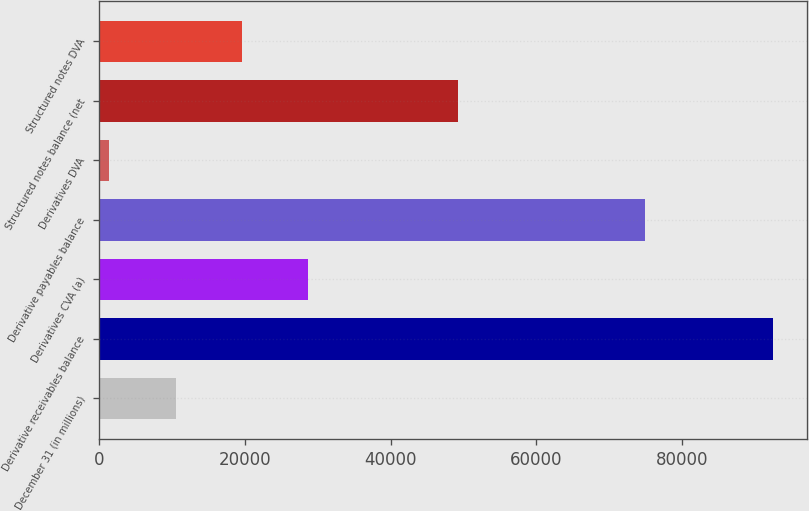<chart> <loc_0><loc_0><loc_500><loc_500><bar_chart><fcel>December 31 (in millions)<fcel>Derivative receivables balance<fcel>Derivatives CVA (a)<fcel>Derivative payables balance<fcel>Derivatives DVA<fcel>Structured notes balance (net<fcel>Structured notes DVA<nl><fcel>10525.7<fcel>92477<fcel>28737.1<fcel>74977<fcel>1420<fcel>49229<fcel>19631.4<nl></chart> 